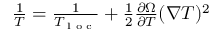Convert formula to latex. <formula><loc_0><loc_0><loc_500><loc_500>\begin{array} { r } { \frac { 1 } { T } = \frac { 1 } { T _ { l o c } } + \frac { 1 } { 2 } \frac { \partial \Omega } { \partial T } ( \nabla T ) ^ { 2 } } \end{array}</formula> 